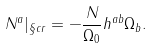<formula> <loc_0><loc_0><loc_500><loc_500>N ^ { a } | _ { \S c r } = - \frac { N } { \Omega _ { 0 } } h ^ { a b } \Omega _ { b } .</formula> 